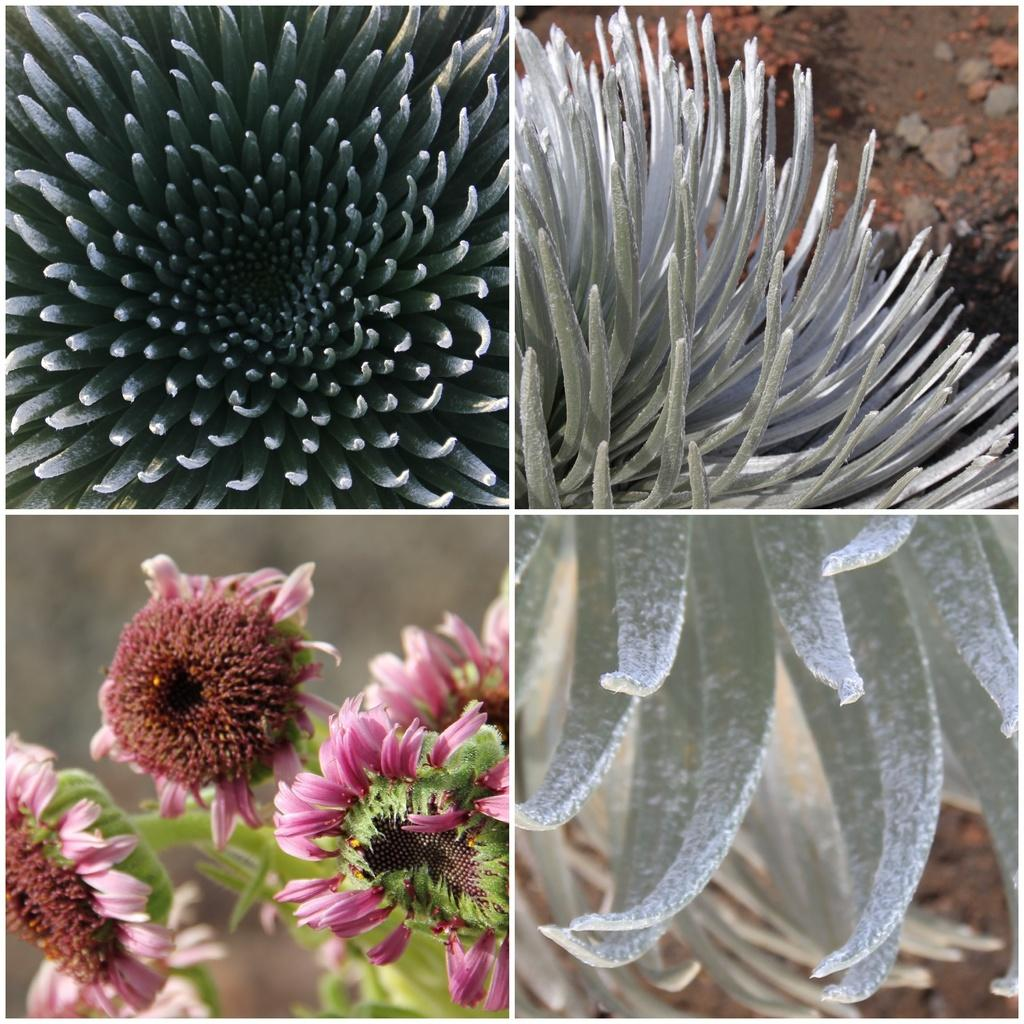What type of artwork is depicted in the image? The image is a collage. What type of flora can be seen in the image? There are flowers and plants in the image. What color is the sock on the zebra in the image? There is no sock or zebra present in the image. How can we help the plants in the image grow better? The image is a static representation and does not require any assistance for the plants to grow. 